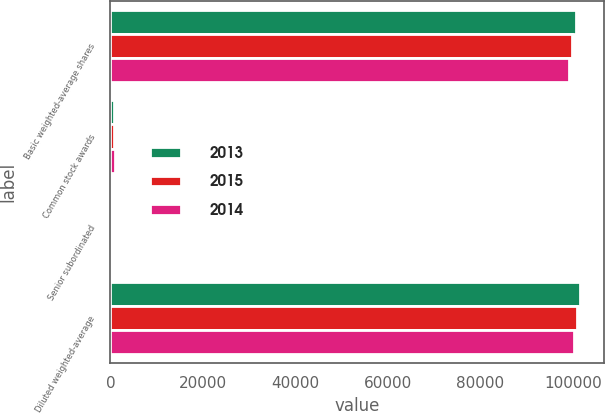Convert chart to OTSL. <chart><loc_0><loc_0><loc_500><loc_500><stacked_bar_chart><ecel><fcel>Basic weighted-average shares<fcel>Common stock awards<fcel>Senior subordinated<fcel>Diluted weighted-average<nl><fcel>2013<fcel>100616<fcel>887<fcel>94<fcel>101597<nl><fcel>2015<fcel>99916<fcel>816<fcel>152<fcel>100884<nl><fcel>2014<fcel>99123<fcel>891<fcel>195<fcel>100209<nl></chart> 